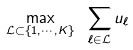<formula> <loc_0><loc_0><loc_500><loc_500>\max _ { { \mathcal { L } } \subset \{ 1 , \cdots , K \} } \ \sum _ { \ell \in { \mathcal { L } } } u _ { \ell }</formula> 